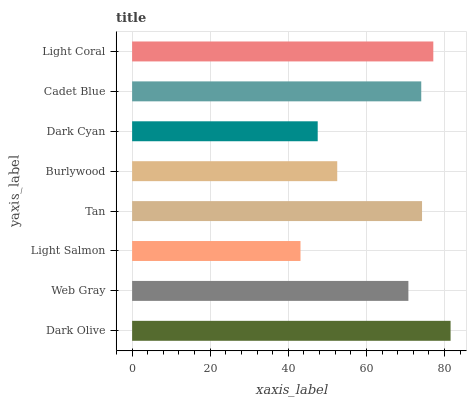Is Light Salmon the minimum?
Answer yes or no. Yes. Is Dark Olive the maximum?
Answer yes or no. Yes. Is Web Gray the minimum?
Answer yes or no. No. Is Web Gray the maximum?
Answer yes or no. No. Is Dark Olive greater than Web Gray?
Answer yes or no. Yes. Is Web Gray less than Dark Olive?
Answer yes or no. Yes. Is Web Gray greater than Dark Olive?
Answer yes or no. No. Is Dark Olive less than Web Gray?
Answer yes or no. No. Is Cadet Blue the high median?
Answer yes or no. Yes. Is Web Gray the low median?
Answer yes or no. Yes. Is Web Gray the high median?
Answer yes or no. No. Is Cadet Blue the low median?
Answer yes or no. No. 